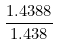Convert formula to latex. <formula><loc_0><loc_0><loc_500><loc_500>\frac { 1 . 4 3 8 8 } { 1 . 4 3 8 }</formula> 